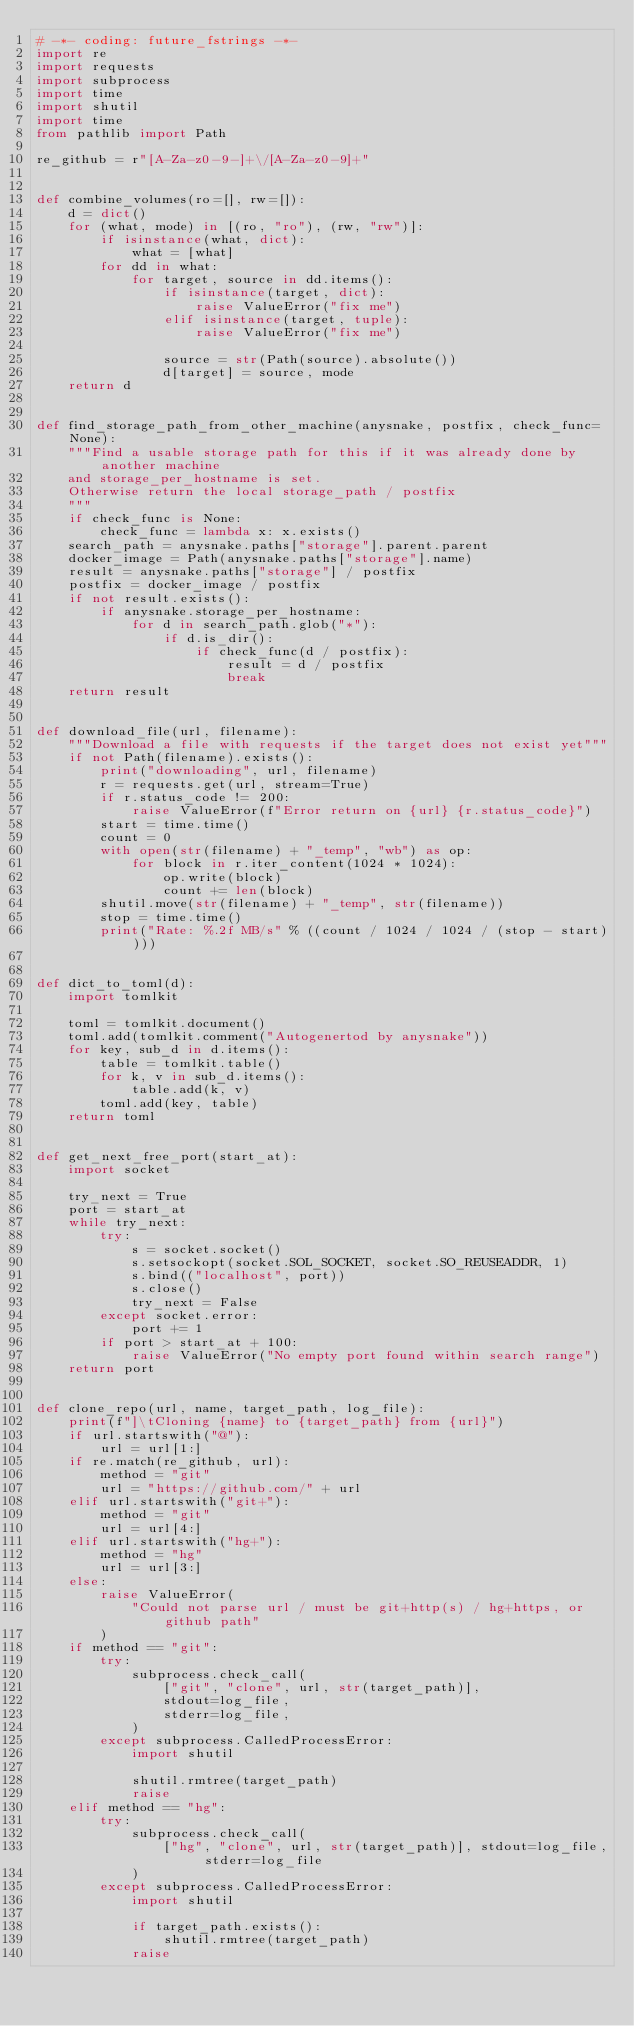<code> <loc_0><loc_0><loc_500><loc_500><_Python_># -*- coding: future_fstrings -*-
import re
import requests
import subprocess
import time
import shutil
import time
from pathlib import Path

re_github = r"[A-Za-z0-9-]+\/[A-Za-z0-9]+"


def combine_volumes(ro=[], rw=[]):
    d = dict()
    for (what, mode) in [(ro, "ro"), (rw, "rw")]:
        if isinstance(what, dict):
            what = [what]
        for dd in what:
            for target, source in dd.items():
                if isinstance(target, dict):
                    raise ValueError("fix me")
                elif isinstance(target, tuple):
                    raise ValueError("fix me")

                source = str(Path(source).absolute())
                d[target] = source, mode
    return d


def find_storage_path_from_other_machine(anysnake, postfix, check_func=None):
    """Find a usable storage path for this if it was already done by another machine
    and storage_per_hostname is set. 
    Otherwise return the local storage_path / postfix
    """
    if check_func is None:
        check_func = lambda x: x.exists()
    search_path = anysnake.paths["storage"].parent.parent
    docker_image = Path(anysnake.paths["storage"].name)
    result = anysnake.paths["storage"] / postfix
    postfix = docker_image / postfix
    if not result.exists():
        if anysnake.storage_per_hostname:
            for d in search_path.glob("*"):
                if d.is_dir():
                    if check_func(d / postfix):
                        result = d / postfix
                        break
    return result


def download_file(url, filename):
    """Download a file with requests if the target does not exist yet"""
    if not Path(filename).exists():
        print("downloading", url, filename)
        r = requests.get(url, stream=True)
        if r.status_code != 200:
            raise ValueError(f"Error return on {url} {r.status_code}")
        start = time.time()
        count = 0
        with open(str(filename) + "_temp", "wb") as op:
            for block in r.iter_content(1024 * 1024):
                op.write(block)
                count += len(block)
        shutil.move(str(filename) + "_temp", str(filename))
        stop = time.time()
        print("Rate: %.2f MB/s" % ((count / 1024 / 1024 / (stop - start))))


def dict_to_toml(d):
    import tomlkit

    toml = tomlkit.document()
    toml.add(tomlkit.comment("Autogenertod by anysnake"))
    for key, sub_d in d.items():
        table = tomlkit.table()
        for k, v in sub_d.items():
            table.add(k, v)
        toml.add(key, table)
    return toml


def get_next_free_port(start_at):
    import socket

    try_next = True
    port = start_at
    while try_next:
        try:
            s = socket.socket()
            s.setsockopt(socket.SOL_SOCKET, socket.SO_REUSEADDR, 1)
            s.bind(("localhost", port))
            s.close()
            try_next = False
        except socket.error:
            port += 1
        if port > start_at + 100:
            raise ValueError("No empty port found within search range")
    return port


def clone_repo(url, name, target_path, log_file):
    print(f"]\tCloning {name} to {target_path} from {url}")
    if url.startswith("@"):
        url = url[1:]
    if re.match(re_github, url):
        method = "git"
        url = "https://github.com/" + url
    elif url.startswith("git+"):
        method = "git"
        url = url[4:]
    elif url.startswith("hg+"):
        method = "hg"
        url = url[3:]
    else:
        raise ValueError(
            "Could not parse url / must be git+http(s) / hg+https, or github path"
        )
    if method == "git":
        try:
            subprocess.check_call(
                ["git", "clone", url, str(target_path)],
                stdout=log_file,
                stderr=log_file,
            )
        except subprocess.CalledProcessError:
            import shutil

            shutil.rmtree(target_path)
            raise
    elif method == "hg":
        try:
            subprocess.check_call(
                ["hg", "clone", url, str(target_path)], stdout=log_file, stderr=log_file
            )
        except subprocess.CalledProcessError:
            import shutil

            if target_path.exists():
                shutil.rmtree(target_path)
            raise
</code> 